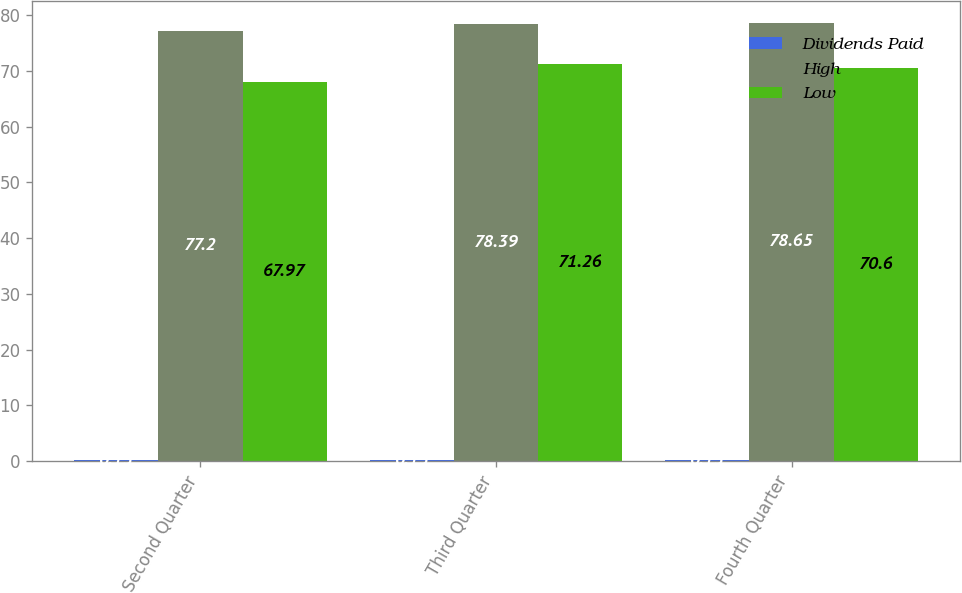Convert chart to OTSL. <chart><loc_0><loc_0><loc_500><loc_500><stacked_bar_chart><ecel><fcel>Second Quarter<fcel>Third Quarter<fcel>Fourth Quarter<nl><fcel>Dividends Paid<fcel>0.15<fcel>0.15<fcel>0.15<nl><fcel>High<fcel>77.2<fcel>78.39<fcel>78.65<nl><fcel>Low<fcel>67.97<fcel>71.26<fcel>70.6<nl></chart> 